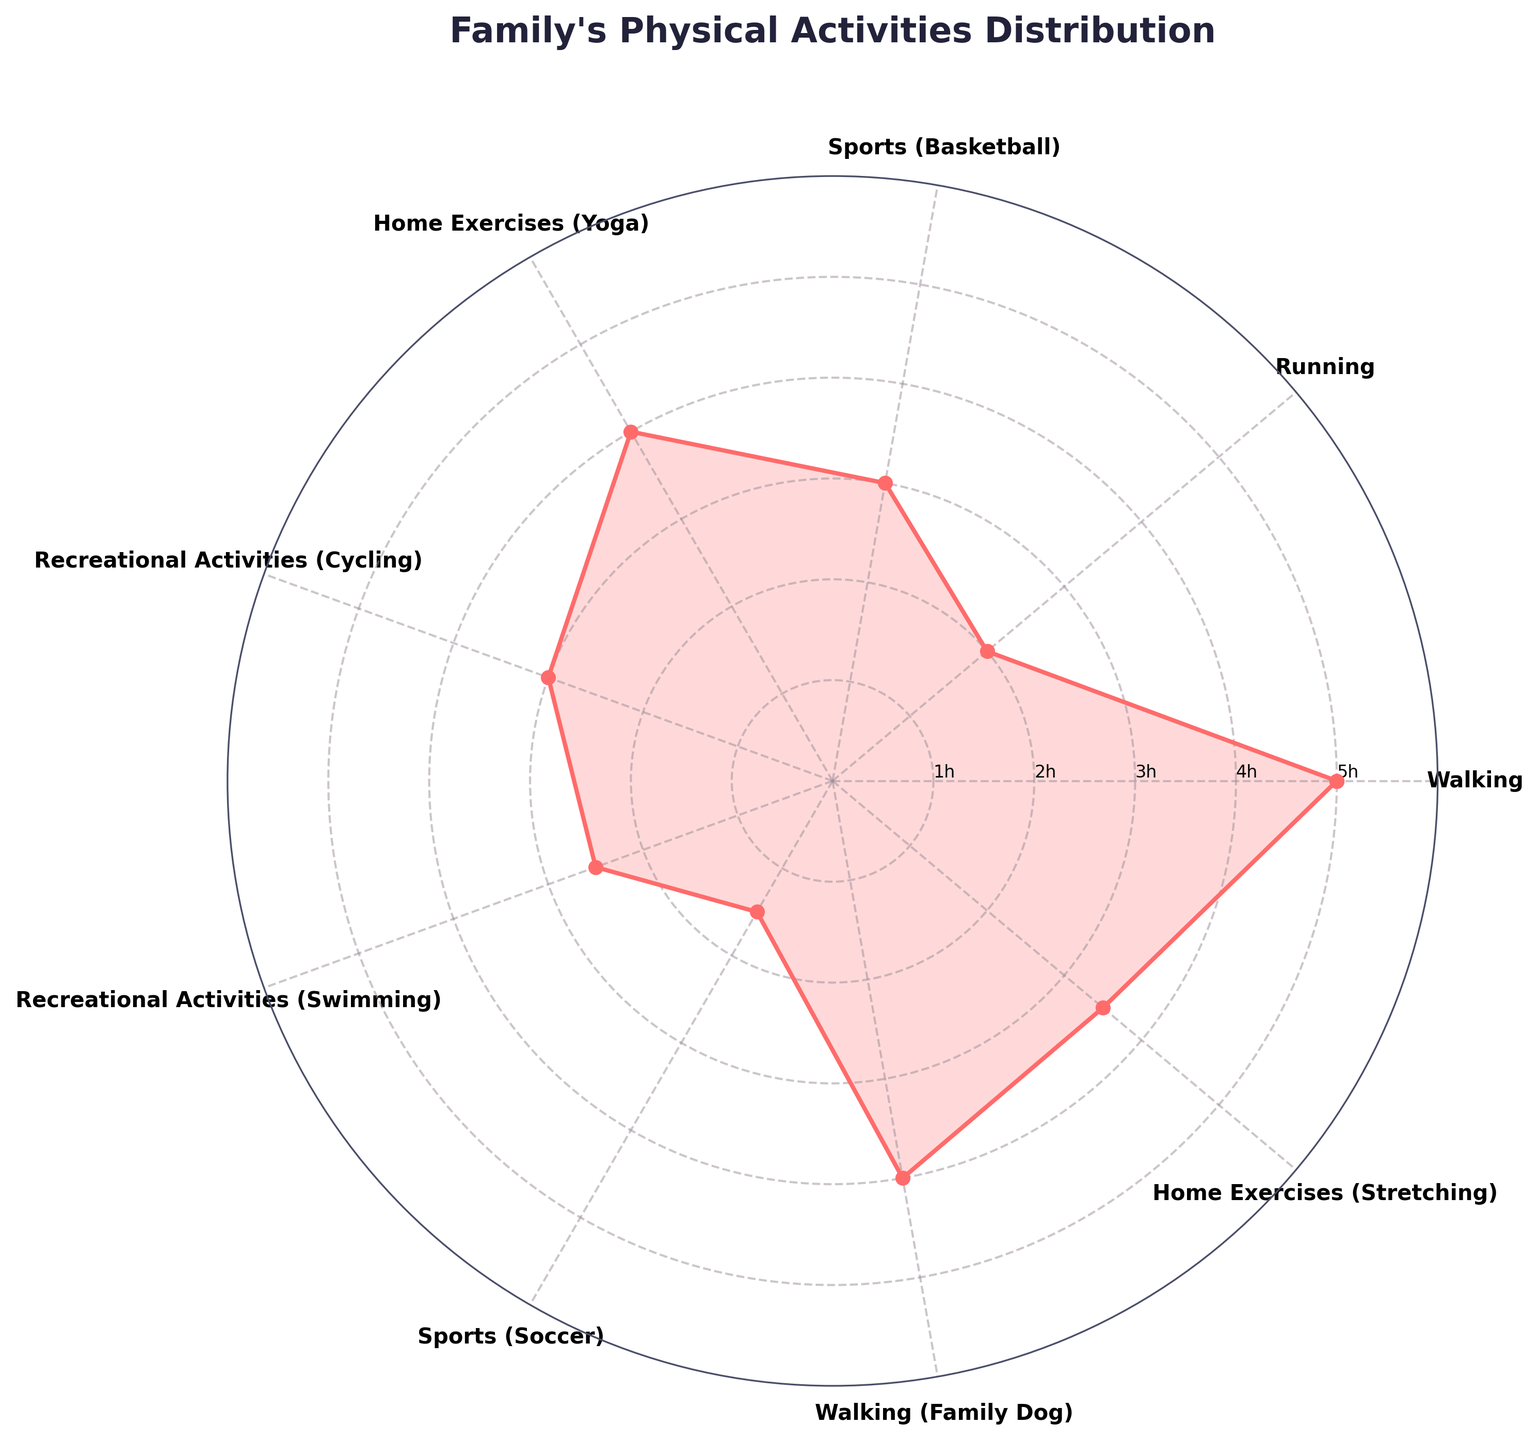what is the title of the chart? The title is positioned at the top of the chart and reads "Family's Physical Activities Distribution".
Answer: Family's Physical Activities Distribution How many types of activities are displayed on the chart? By counting the labels around the chart, we can see there are 9 different activities listed.
Answer: 9 What activity has the highest hours per week? Find the activity corresponding to the highest point on the radial axis. "Walking" and "Walking (Family Dog)" both have 5 hours per week.
Answer: Walking and Walking (Family Dog) Which activity has the least hours spent per week? Locate the activity closest to the center of the chart. It's "Sports (Soccer)" with 1.5 hours per week.
Answer: Sports (Soccer) What is the average number of hours spent on home exercises? Add the hours for "Home Exercises (Yoga)" and "Home Exercises (Stretching)" and divide by 2. This is (4 + 3.5)/2 = 3.75 hours per week.
Answer: 3.75 How many hours are spent on recreational activities in total? Sum the hours for "Recreational Activities (Cycling)" and "Recreational Activities (Swimming)". This is 3 + 2.5 = 5.5 hours per week.
Answer: 5.5 Compare the hours spent on sports activities such as Basketball and Soccer. Subtract the hours for "Sports (Soccer)" from "Sports (Basketball)". This is 3 - 1.5 = 1.5 hours per week more on Basketball.
Answer: 1.5 more on Basketball Which category, sports or home exercises, has more total hours? Add hours for all sports and home exercises, then compare. Sports: 3 (Basketball) + 1.5 (Soccer) = 4.5. Home Exercises: 4 (Yoga) + 3.5 (Stretching) = 7.5.
Answer: Home exercises What is the combined time spent on walking activities? Add the hours for "Walking" and "Walking (Family Dog)". This is 5 + 4 = 9 hours per week.
Answer: 9 hours Which activity has more time spent: Yoga or Stretching? Directly compare the hours per week for "Home Exercises (Yoga)" and "Home Exercises (Stretching)". Yoga has 4 hours, while Stretching has 3.5 hours per week.
Answer: Yoga 